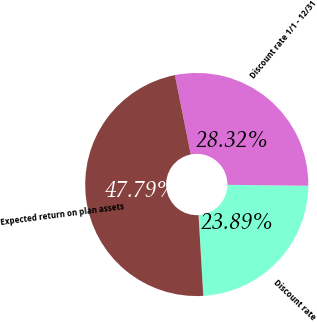Convert chart to OTSL. <chart><loc_0><loc_0><loc_500><loc_500><pie_chart><fcel>Discount rate<fcel>Discount rate 1/1 - 12/31<fcel>Expected return on plan assets<nl><fcel>23.89%<fcel>28.32%<fcel>47.79%<nl></chart> 